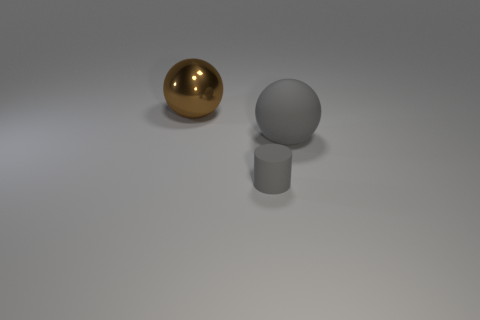Are there any other things that are made of the same material as the big brown sphere?
Provide a succinct answer. No. There is a object that is made of the same material as the cylinder; what shape is it?
Keep it short and to the point. Sphere. How many tiny objects are either yellow cylinders or gray matte cylinders?
Provide a succinct answer. 1. How many other things are there of the same color as the big rubber sphere?
Ensure brevity in your answer.  1. How many large gray matte things are on the left side of the big object right of the ball that is to the left of the large rubber object?
Your answer should be compact. 0. There is a sphere in front of the brown object; is it the same size as the brown metallic thing?
Offer a very short reply. Yes. Is the number of gray things that are in front of the large brown shiny sphere less than the number of tiny cylinders left of the gray rubber ball?
Make the answer very short. No. Is the color of the tiny rubber object the same as the matte sphere?
Provide a short and direct response. Yes. Are there fewer large rubber balls that are to the left of the rubber cylinder than green balls?
Offer a terse response. No. What material is the large sphere that is the same color as the small cylinder?
Ensure brevity in your answer.  Rubber. 